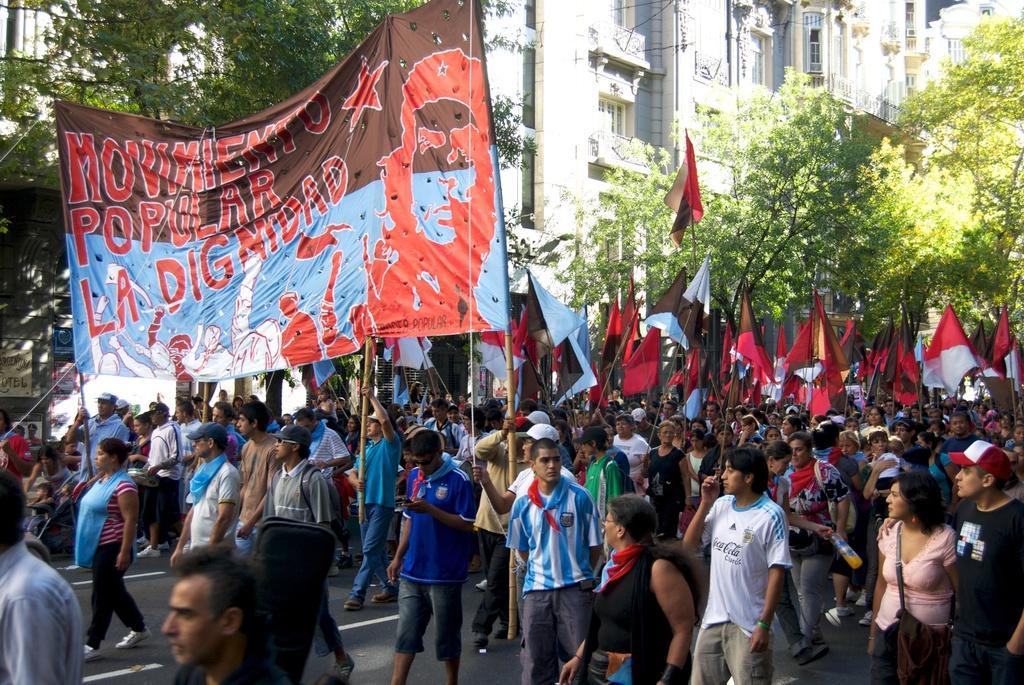In one or two sentences, can you explain what this image depicts? Group of people are walking by holding the banners and flags. On the right side there are trees, in the middle there are buildings. 